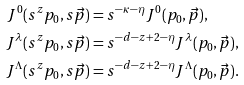<formula> <loc_0><loc_0><loc_500><loc_500>J ^ { 0 } ( s ^ { z } p _ { 0 } , s \vec { p } ) & = s ^ { - \kappa - \eta } J ^ { 0 } ( p _ { 0 } , \vec { p } ) , \\ J ^ { \lambda } ( s ^ { z } p _ { 0 } , s \vec { p } ) & = s ^ { - d - z + 2 - \eta } J ^ { \lambda } ( p _ { 0 } , \vec { p } ) , \\ J ^ { \Lambda } ( s ^ { z } p _ { 0 } , s \vec { p } ) & = s ^ { - d - z + 2 - \eta } J ^ { \Lambda } ( p _ { 0 } , \vec { p } ) .</formula> 